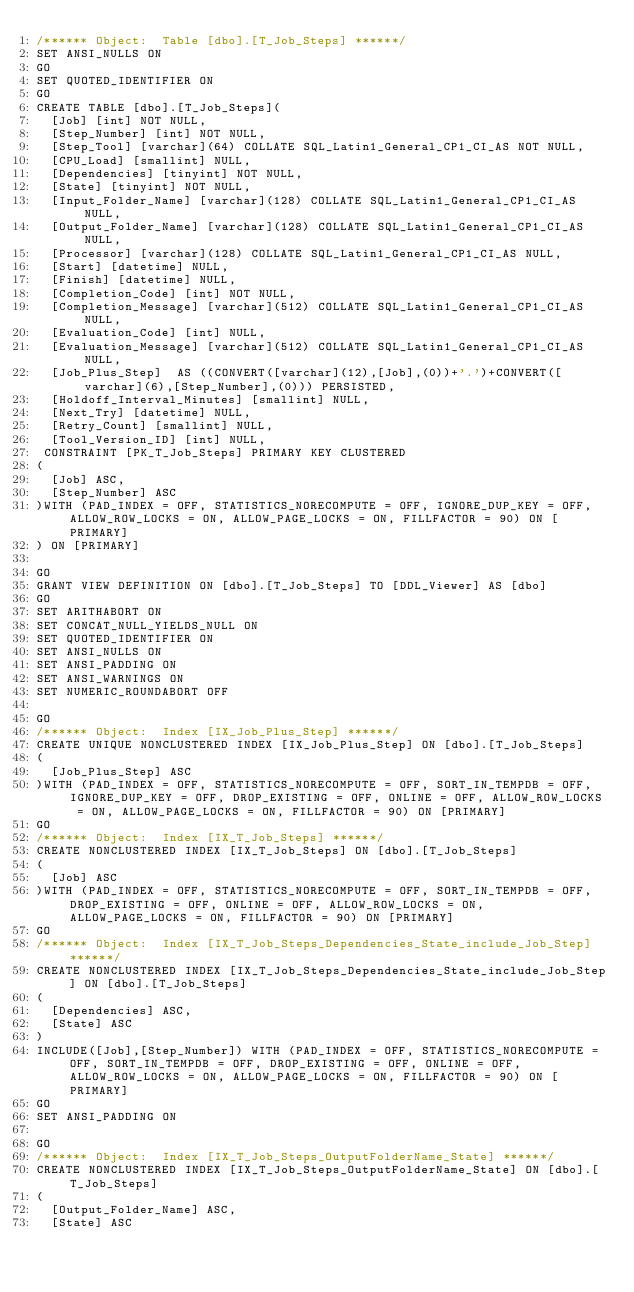<code> <loc_0><loc_0><loc_500><loc_500><_SQL_>/****** Object:  Table [dbo].[T_Job_Steps] ******/
SET ANSI_NULLS ON
GO
SET QUOTED_IDENTIFIER ON
GO
CREATE TABLE [dbo].[T_Job_Steps](
	[Job] [int] NOT NULL,
	[Step_Number] [int] NOT NULL,
	[Step_Tool] [varchar](64) COLLATE SQL_Latin1_General_CP1_CI_AS NOT NULL,
	[CPU_Load] [smallint] NULL,
	[Dependencies] [tinyint] NOT NULL,
	[State] [tinyint] NOT NULL,
	[Input_Folder_Name] [varchar](128) COLLATE SQL_Latin1_General_CP1_CI_AS NULL,
	[Output_Folder_Name] [varchar](128) COLLATE SQL_Latin1_General_CP1_CI_AS NULL,
	[Processor] [varchar](128) COLLATE SQL_Latin1_General_CP1_CI_AS NULL,
	[Start] [datetime] NULL,
	[Finish] [datetime] NULL,
	[Completion_Code] [int] NOT NULL,
	[Completion_Message] [varchar](512) COLLATE SQL_Latin1_General_CP1_CI_AS NULL,
	[Evaluation_Code] [int] NULL,
	[Evaluation_Message] [varchar](512) COLLATE SQL_Latin1_General_CP1_CI_AS NULL,
	[Job_Plus_Step]  AS ((CONVERT([varchar](12),[Job],(0))+'.')+CONVERT([varchar](6),[Step_Number],(0))) PERSISTED,
	[Holdoff_Interval_Minutes] [smallint] NULL,
	[Next_Try] [datetime] NULL,
	[Retry_Count] [smallint] NULL,
	[Tool_Version_ID] [int] NULL,
 CONSTRAINT [PK_T_Job_Steps] PRIMARY KEY CLUSTERED 
(
	[Job] ASC,
	[Step_Number] ASC
)WITH (PAD_INDEX = OFF, STATISTICS_NORECOMPUTE = OFF, IGNORE_DUP_KEY = OFF, ALLOW_ROW_LOCKS = ON, ALLOW_PAGE_LOCKS = ON, FILLFACTOR = 90) ON [PRIMARY]
) ON [PRIMARY]

GO
GRANT VIEW DEFINITION ON [dbo].[T_Job_Steps] TO [DDL_Viewer] AS [dbo]
GO
SET ARITHABORT ON
SET CONCAT_NULL_YIELDS_NULL ON
SET QUOTED_IDENTIFIER ON
SET ANSI_NULLS ON
SET ANSI_PADDING ON
SET ANSI_WARNINGS ON
SET NUMERIC_ROUNDABORT OFF

GO
/****** Object:  Index [IX_Job_Plus_Step] ******/
CREATE UNIQUE NONCLUSTERED INDEX [IX_Job_Plus_Step] ON [dbo].[T_Job_Steps]
(
	[Job_Plus_Step] ASC
)WITH (PAD_INDEX = OFF, STATISTICS_NORECOMPUTE = OFF, SORT_IN_TEMPDB = OFF, IGNORE_DUP_KEY = OFF, DROP_EXISTING = OFF, ONLINE = OFF, ALLOW_ROW_LOCKS = ON, ALLOW_PAGE_LOCKS = ON, FILLFACTOR = 90) ON [PRIMARY]
GO
/****** Object:  Index [IX_T_Job_Steps] ******/
CREATE NONCLUSTERED INDEX [IX_T_Job_Steps] ON [dbo].[T_Job_Steps]
(
	[Job] ASC
)WITH (PAD_INDEX = OFF, STATISTICS_NORECOMPUTE = OFF, SORT_IN_TEMPDB = OFF, DROP_EXISTING = OFF, ONLINE = OFF, ALLOW_ROW_LOCKS = ON, ALLOW_PAGE_LOCKS = ON, FILLFACTOR = 90) ON [PRIMARY]
GO
/****** Object:  Index [IX_T_Job_Steps_Dependencies_State_include_Job_Step] ******/
CREATE NONCLUSTERED INDEX [IX_T_Job_Steps_Dependencies_State_include_Job_Step] ON [dbo].[T_Job_Steps]
(
	[Dependencies] ASC,
	[State] ASC
)
INCLUDE([Job],[Step_Number]) WITH (PAD_INDEX = OFF, STATISTICS_NORECOMPUTE = OFF, SORT_IN_TEMPDB = OFF, DROP_EXISTING = OFF, ONLINE = OFF, ALLOW_ROW_LOCKS = ON, ALLOW_PAGE_LOCKS = ON, FILLFACTOR = 90) ON [PRIMARY]
GO
SET ANSI_PADDING ON

GO
/****** Object:  Index [IX_T_Job_Steps_OutputFolderName_State] ******/
CREATE NONCLUSTERED INDEX [IX_T_Job_Steps_OutputFolderName_State] ON [dbo].[T_Job_Steps]
(
	[Output_Folder_Name] ASC,
	[State] ASC</code> 